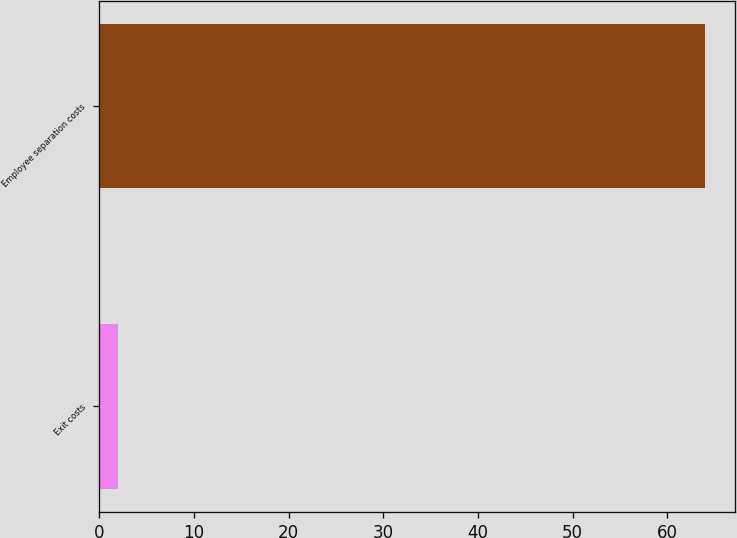Convert chart. <chart><loc_0><loc_0><loc_500><loc_500><bar_chart><fcel>Exit costs<fcel>Employee separation costs<nl><fcel>2<fcel>64<nl></chart> 